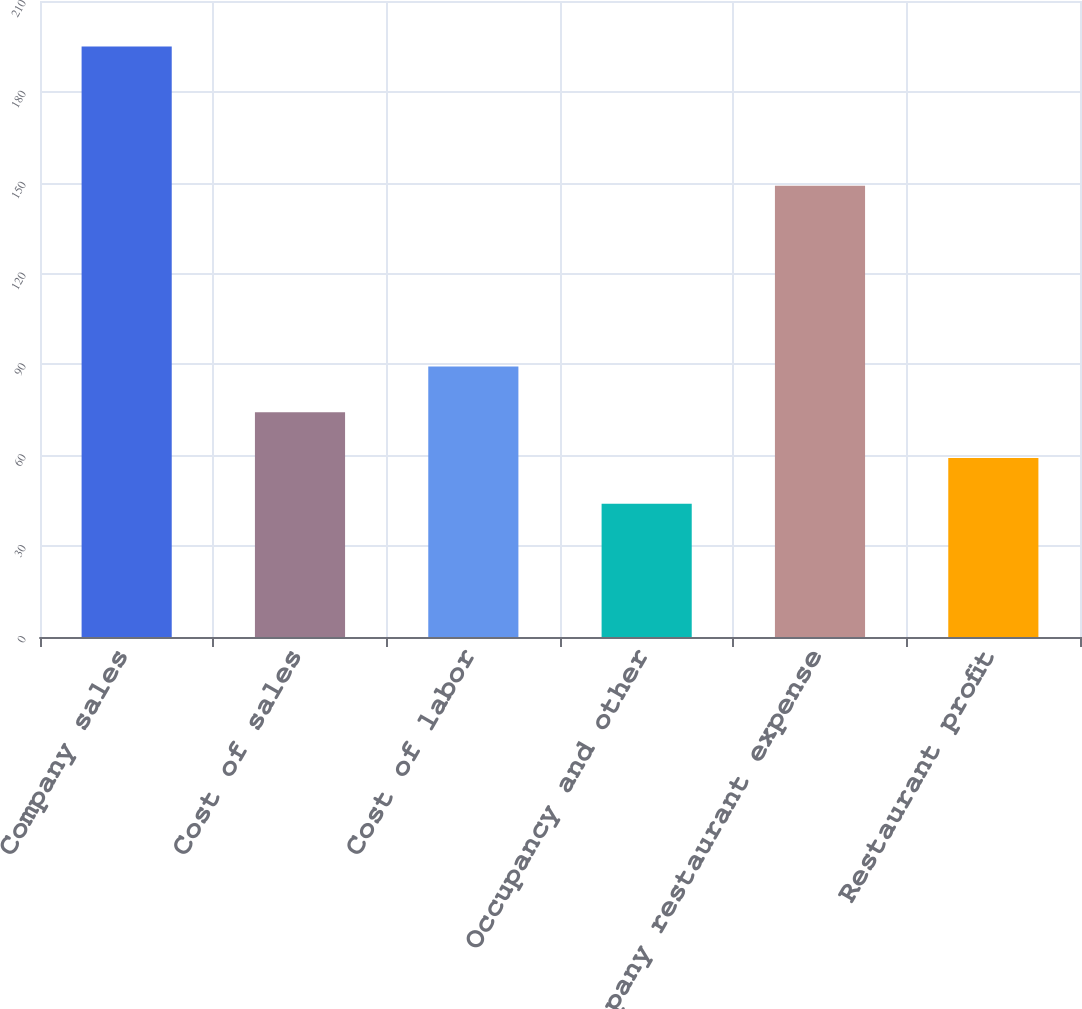<chart> <loc_0><loc_0><loc_500><loc_500><bar_chart><fcel>Company sales<fcel>Cost of sales<fcel>Cost of labor<fcel>Occupancy and other<fcel>Company restaurant expense<fcel>Restaurant profit<nl><fcel>195<fcel>74.2<fcel>89.3<fcel>44<fcel>149<fcel>59.1<nl></chart> 